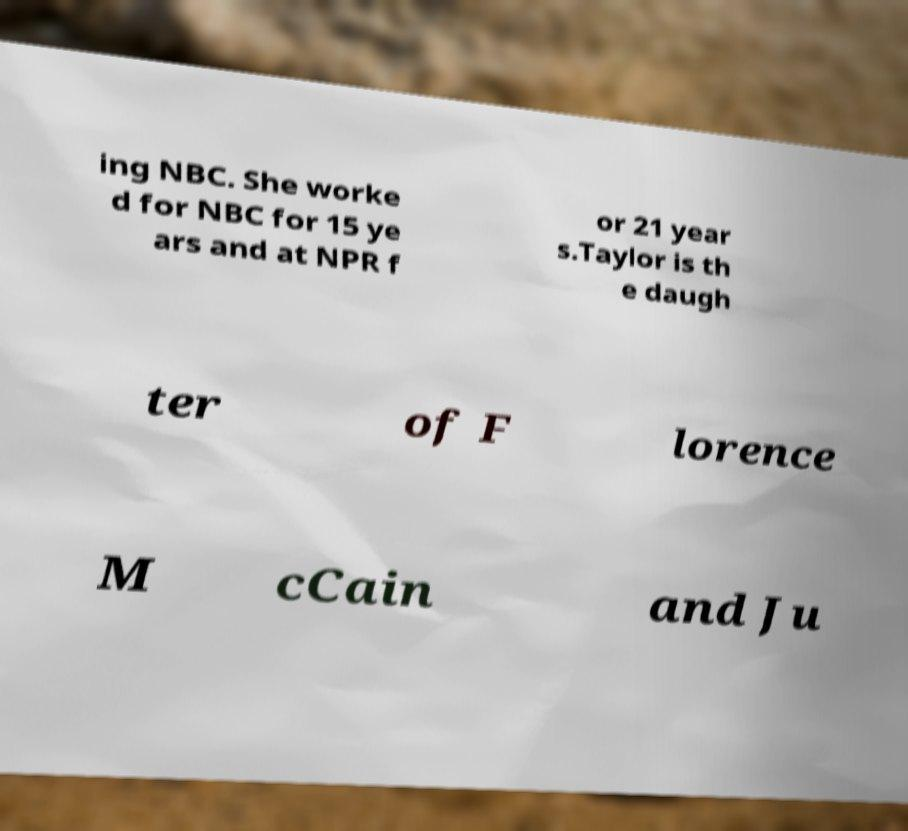For documentation purposes, I need the text within this image transcribed. Could you provide that? ing NBC. She worke d for NBC for 15 ye ars and at NPR f or 21 year s.Taylor is th e daugh ter of F lorence M cCain and Ju 